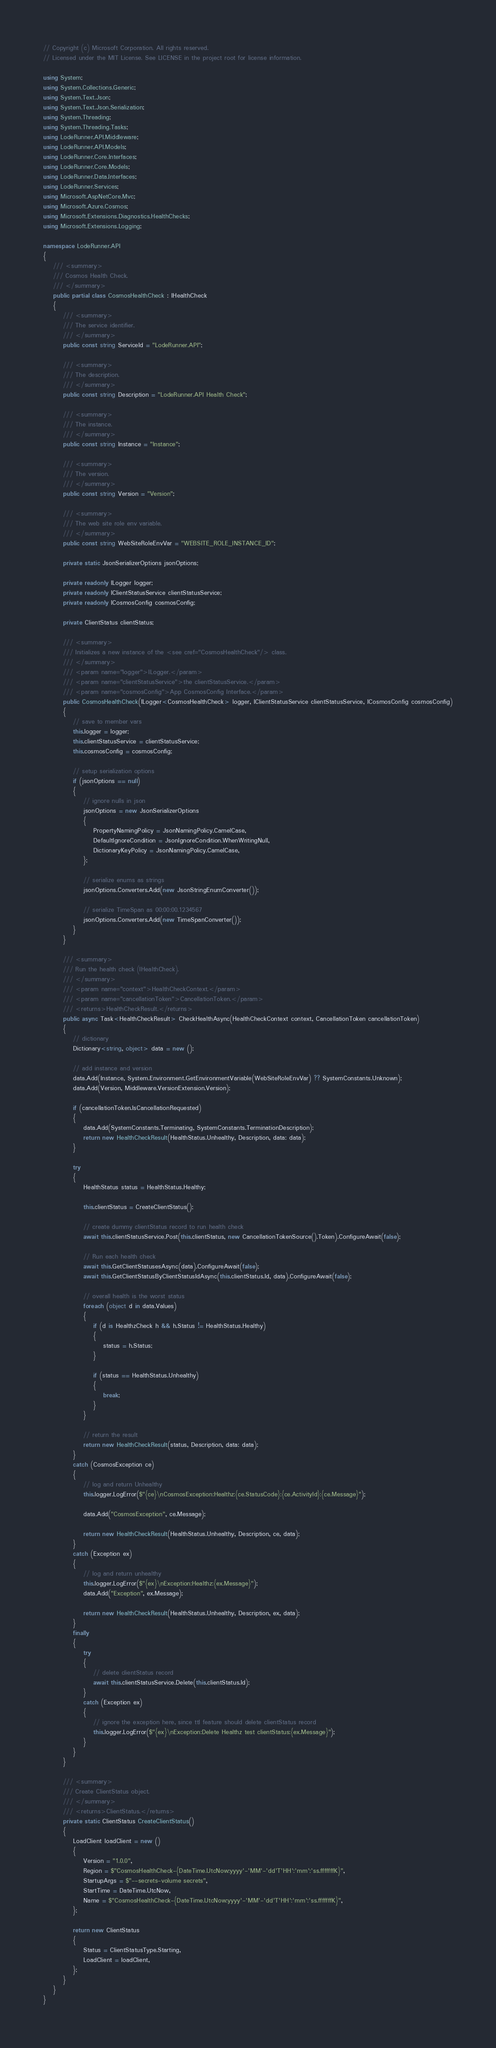<code> <loc_0><loc_0><loc_500><loc_500><_C#_>// Copyright (c) Microsoft Corporation. All rights reserved.
// Licensed under the MIT License. See LICENSE in the project root for license information.

using System;
using System.Collections.Generic;
using System.Text.Json;
using System.Text.Json.Serialization;
using System.Threading;
using System.Threading.Tasks;
using LodeRunner.API.Middleware;
using LodeRunner.API.Models;
using LodeRunner.Core.Interfaces;
using LodeRunner.Core.Models;
using LodeRunner.Data.Interfaces;
using LodeRunner.Services;
using Microsoft.AspNetCore.Mvc;
using Microsoft.Azure.Cosmos;
using Microsoft.Extensions.Diagnostics.HealthChecks;
using Microsoft.Extensions.Logging;

namespace LodeRunner.API
{
    /// <summary>
    /// Cosmos Health Check.
    /// </summary>
    public partial class CosmosHealthCheck : IHealthCheck
    {
        /// <summary>
        /// The service identifier.
        /// </summary>
        public const string ServiceId = "LodeRunner.API";

        /// <summary>
        /// The description.
        /// </summary>
        public const string Description = "LodeRunner.API Health Check";

        /// <summary>
        /// The instance.
        /// </summary>
        public const string Instance = "Instance";

        /// <summary>
        /// The version.
        /// </summary>
        public const string Version = "Version";

        /// <summary>
        /// The web site role env variable.
        /// </summary>
        public const string WebSiteRoleEnvVar = "WEBSITE_ROLE_INSTANCE_ID";

        private static JsonSerializerOptions jsonOptions;

        private readonly ILogger logger;
        private readonly IClientStatusService clientStatusService;
        private readonly ICosmosConfig cosmosConfig;

        private ClientStatus clientStatus;

        /// <summary>
        /// Initializes a new instance of the <see cref="CosmosHealthCheck"/> class.
        /// </summary>
        /// <param name="logger">ILogger.</param>
        /// <param name="clientStatusService">the clientStatusService.</param>
        /// <param name="cosmosConfig">App CosmosConfig Interface.</param>
        public CosmosHealthCheck(ILogger<CosmosHealthCheck> logger, IClientStatusService clientStatusService, ICosmosConfig cosmosConfig)
        {
            // save to member vars
            this.logger = logger;
            this.clientStatusService = clientStatusService;
            this.cosmosConfig = cosmosConfig;

            // setup serialization options
            if (jsonOptions == null)
            {
                // ignore nulls in json
                jsonOptions = new JsonSerializerOptions
                {
                    PropertyNamingPolicy = JsonNamingPolicy.CamelCase,
                    DefaultIgnoreCondition = JsonIgnoreCondition.WhenWritingNull,
                    DictionaryKeyPolicy = JsonNamingPolicy.CamelCase,
                };

                // serialize enums as strings
                jsonOptions.Converters.Add(new JsonStringEnumConverter());

                // serialize TimeSpan as 00:00:00.1234567
                jsonOptions.Converters.Add(new TimeSpanConverter());
            }
        }

        /// <summary>
        /// Run the health check (IHealthCheck).
        /// </summary>
        /// <param name="context">HealthCheckContext.</param>
        /// <param name="cancellationToken">CancellationToken.</param>
        /// <returns>HealthCheckResult.</returns>
        public async Task<HealthCheckResult> CheckHealthAsync(HealthCheckContext context, CancellationToken cancellationToken)
        {
            // dictionary
            Dictionary<string, object> data = new ();

            // add instance and version
            data.Add(Instance, System.Environment.GetEnvironmentVariable(WebSiteRoleEnvVar) ?? SystemConstants.Unknown);
            data.Add(Version, Middleware.VersionExtension.Version);

            if (cancellationToken.IsCancellationRequested)
            {
                data.Add(SystemConstants.Terminating, SystemConstants.TerminationDescription);
                return new HealthCheckResult(HealthStatus.Unhealthy, Description, data: data);
            }

            try
            {
                HealthStatus status = HealthStatus.Healthy;

                this.clientStatus = CreateClientStatus();

                // create dummy clientStatus record to run health check
                await this.clientStatusService.Post(this.clientStatus, new CancellationTokenSource().Token).ConfigureAwait(false);

                // Run each health check
                await this.GetClientStatusesAsync(data).ConfigureAwait(false);
                await this.GetClientStatusByClientStatusIdAsync(this.clientStatus.Id, data).ConfigureAwait(false);

                // overall health is the worst status
                foreach (object d in data.Values)
                {
                    if (d is HealthzCheck h && h.Status != HealthStatus.Healthy)
                    {
                        status = h.Status;
                    }

                    if (status == HealthStatus.Unhealthy)
                    {
                        break;
                    }
                }

                // return the result
                return new HealthCheckResult(status, Description, data: data);
            }
            catch (CosmosException ce)
            {
                // log and return Unhealthy
                this.logger.LogError($"{ce}\nCosmosException:Healthz:{ce.StatusCode}:{ce.ActivityId}:{ce.Message}");

                data.Add("CosmosException", ce.Message);

                return new HealthCheckResult(HealthStatus.Unhealthy, Description, ce, data);
            }
            catch (Exception ex)
            {
                // log and return unhealthy
                this.logger.LogError($"{ex}\nException:Healthz:{ex.Message}");
                data.Add("Exception", ex.Message);

                return new HealthCheckResult(HealthStatus.Unhealthy, Description, ex, data);
            }
            finally
            {
                try
                {
                    // delete clientStatus record
                    await this.clientStatusService.Delete(this.clientStatus.Id);
                }
                catch (Exception ex)
                {
                    // ignore the exception here, since ttl feature should delete clientStatus record
                    this.logger.LogError($"{ex}\nException:Delete Healthz test clientStatus:{ex.Message}");
                }
            }
        }

        /// <summary>
        /// Create ClientStatus object.
        /// </summary>
        /// <returns>ClientStatus.</returns>
        private static ClientStatus CreateClientStatus()
        {
            LoadClient loadClient = new ()
            {
                Version = "1.0.0",
                Region = $"CosmosHealthCheck-{DateTime.UtcNow:yyyy'-'MM'-'dd'T'HH':'mm':'ss.fffffffK}",
                StartupArgs = $"--secrets-volume secrets",
                StartTime = DateTime.UtcNow,
                Name = $"CosmosHealthCheck-{DateTime.UtcNow:yyyy'-'MM'-'dd'T'HH':'mm':'ss.fffffffK}",
            };

            return new ClientStatus
            {
                Status = ClientStatusType.Starting,
                LoadClient = loadClient,
            };
        }
    }
}
</code> 